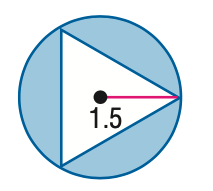Answer the mathemtical geometry problem and directly provide the correct option letter.
Question: Find the area of the shaded region. Assume that all polygons that appear to be regular are regular. Round to the nearest tenth.
Choices: A: 1.2 B: 4.1 C: 5.4 D: 7.1 B 